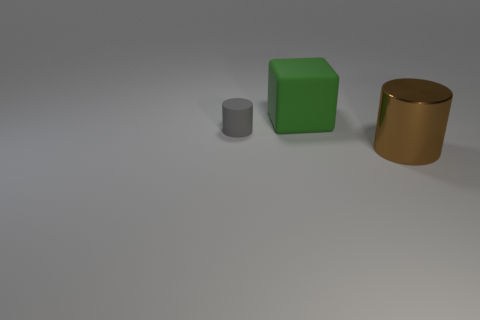The thing behind the cylinder that is to the left of the brown metallic object is made of what material?
Offer a very short reply. Rubber. What number of other tiny objects are the same shape as the brown metal object?
Ensure brevity in your answer.  1. What is the shape of the tiny gray object?
Provide a succinct answer. Cylinder. Are there fewer large brown metallic cylinders than large red rubber spheres?
Make the answer very short. No. Is there anything else that is the same size as the metal object?
Ensure brevity in your answer.  Yes. There is another large object that is the same shape as the gray thing; what material is it?
Provide a succinct answer. Metal. Are there more green rubber objects than tiny green metal blocks?
Your answer should be very brief. Yes. Is the material of the gray cylinder the same as the object that is in front of the tiny thing?
Provide a short and direct response. No. There is a large rubber block right of the cylinder that is left of the brown metal cylinder; how many rubber cylinders are to the left of it?
Provide a short and direct response. 1. Is the number of large brown objects that are on the right side of the big brown metal cylinder less than the number of tiny gray rubber cylinders that are in front of the tiny rubber cylinder?
Offer a terse response. No. 